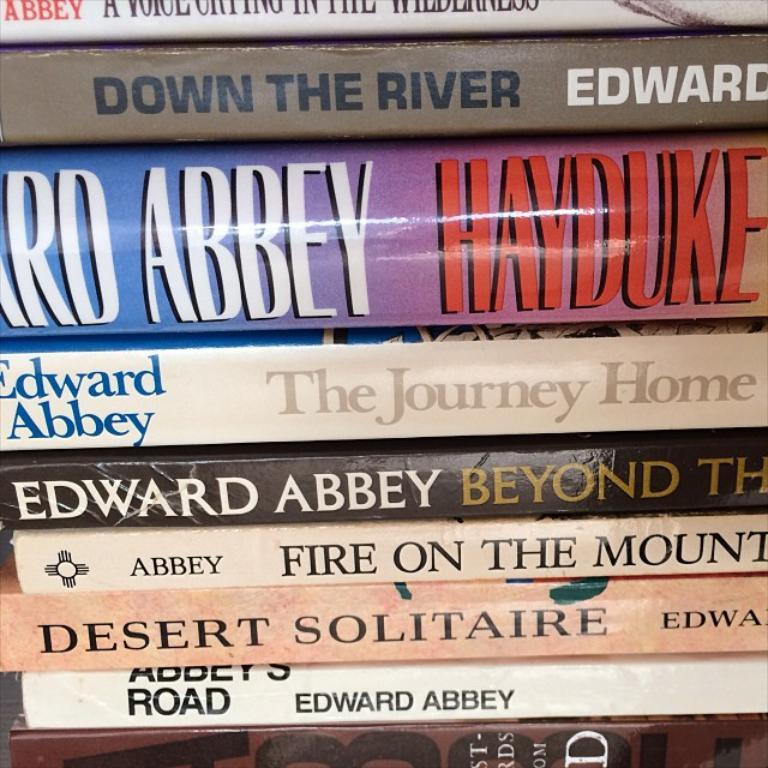Provide a one-sentence caption for the provided image. the name Edward Abbey is on a couple books. 